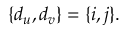Convert formula to latex. <formula><loc_0><loc_0><loc_500><loc_500>\{ d _ { u } , d _ { v } \} = \{ i , j \} .</formula> 